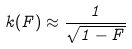Convert formula to latex. <formula><loc_0><loc_0><loc_500><loc_500>k ( F ) \approx \frac { 1 } { \sqrt { 1 - F } }</formula> 